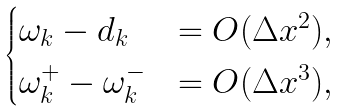<formula> <loc_0><loc_0><loc_500><loc_500>\begin{cases} \omega _ { k } - d _ { k } & = O ( \Delta x ^ { 2 } ) , \\ \omega _ { k } ^ { + } - \omega _ { k } ^ { - } & = O ( \Delta x ^ { 3 } ) , \end{cases}</formula> 